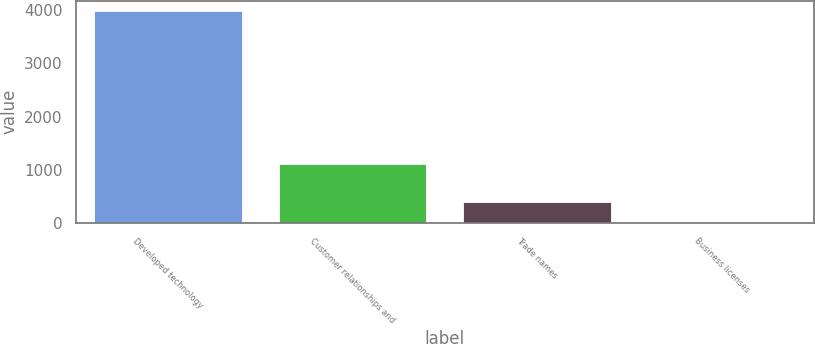Convert chart to OTSL. <chart><loc_0><loc_0><loc_500><loc_500><bar_chart><fcel>Developed technology<fcel>Customer relationships and<fcel>Trade names<fcel>Business licenses<nl><fcel>3979.1<fcel>1101.1<fcel>400.16<fcel>2.5<nl></chart> 